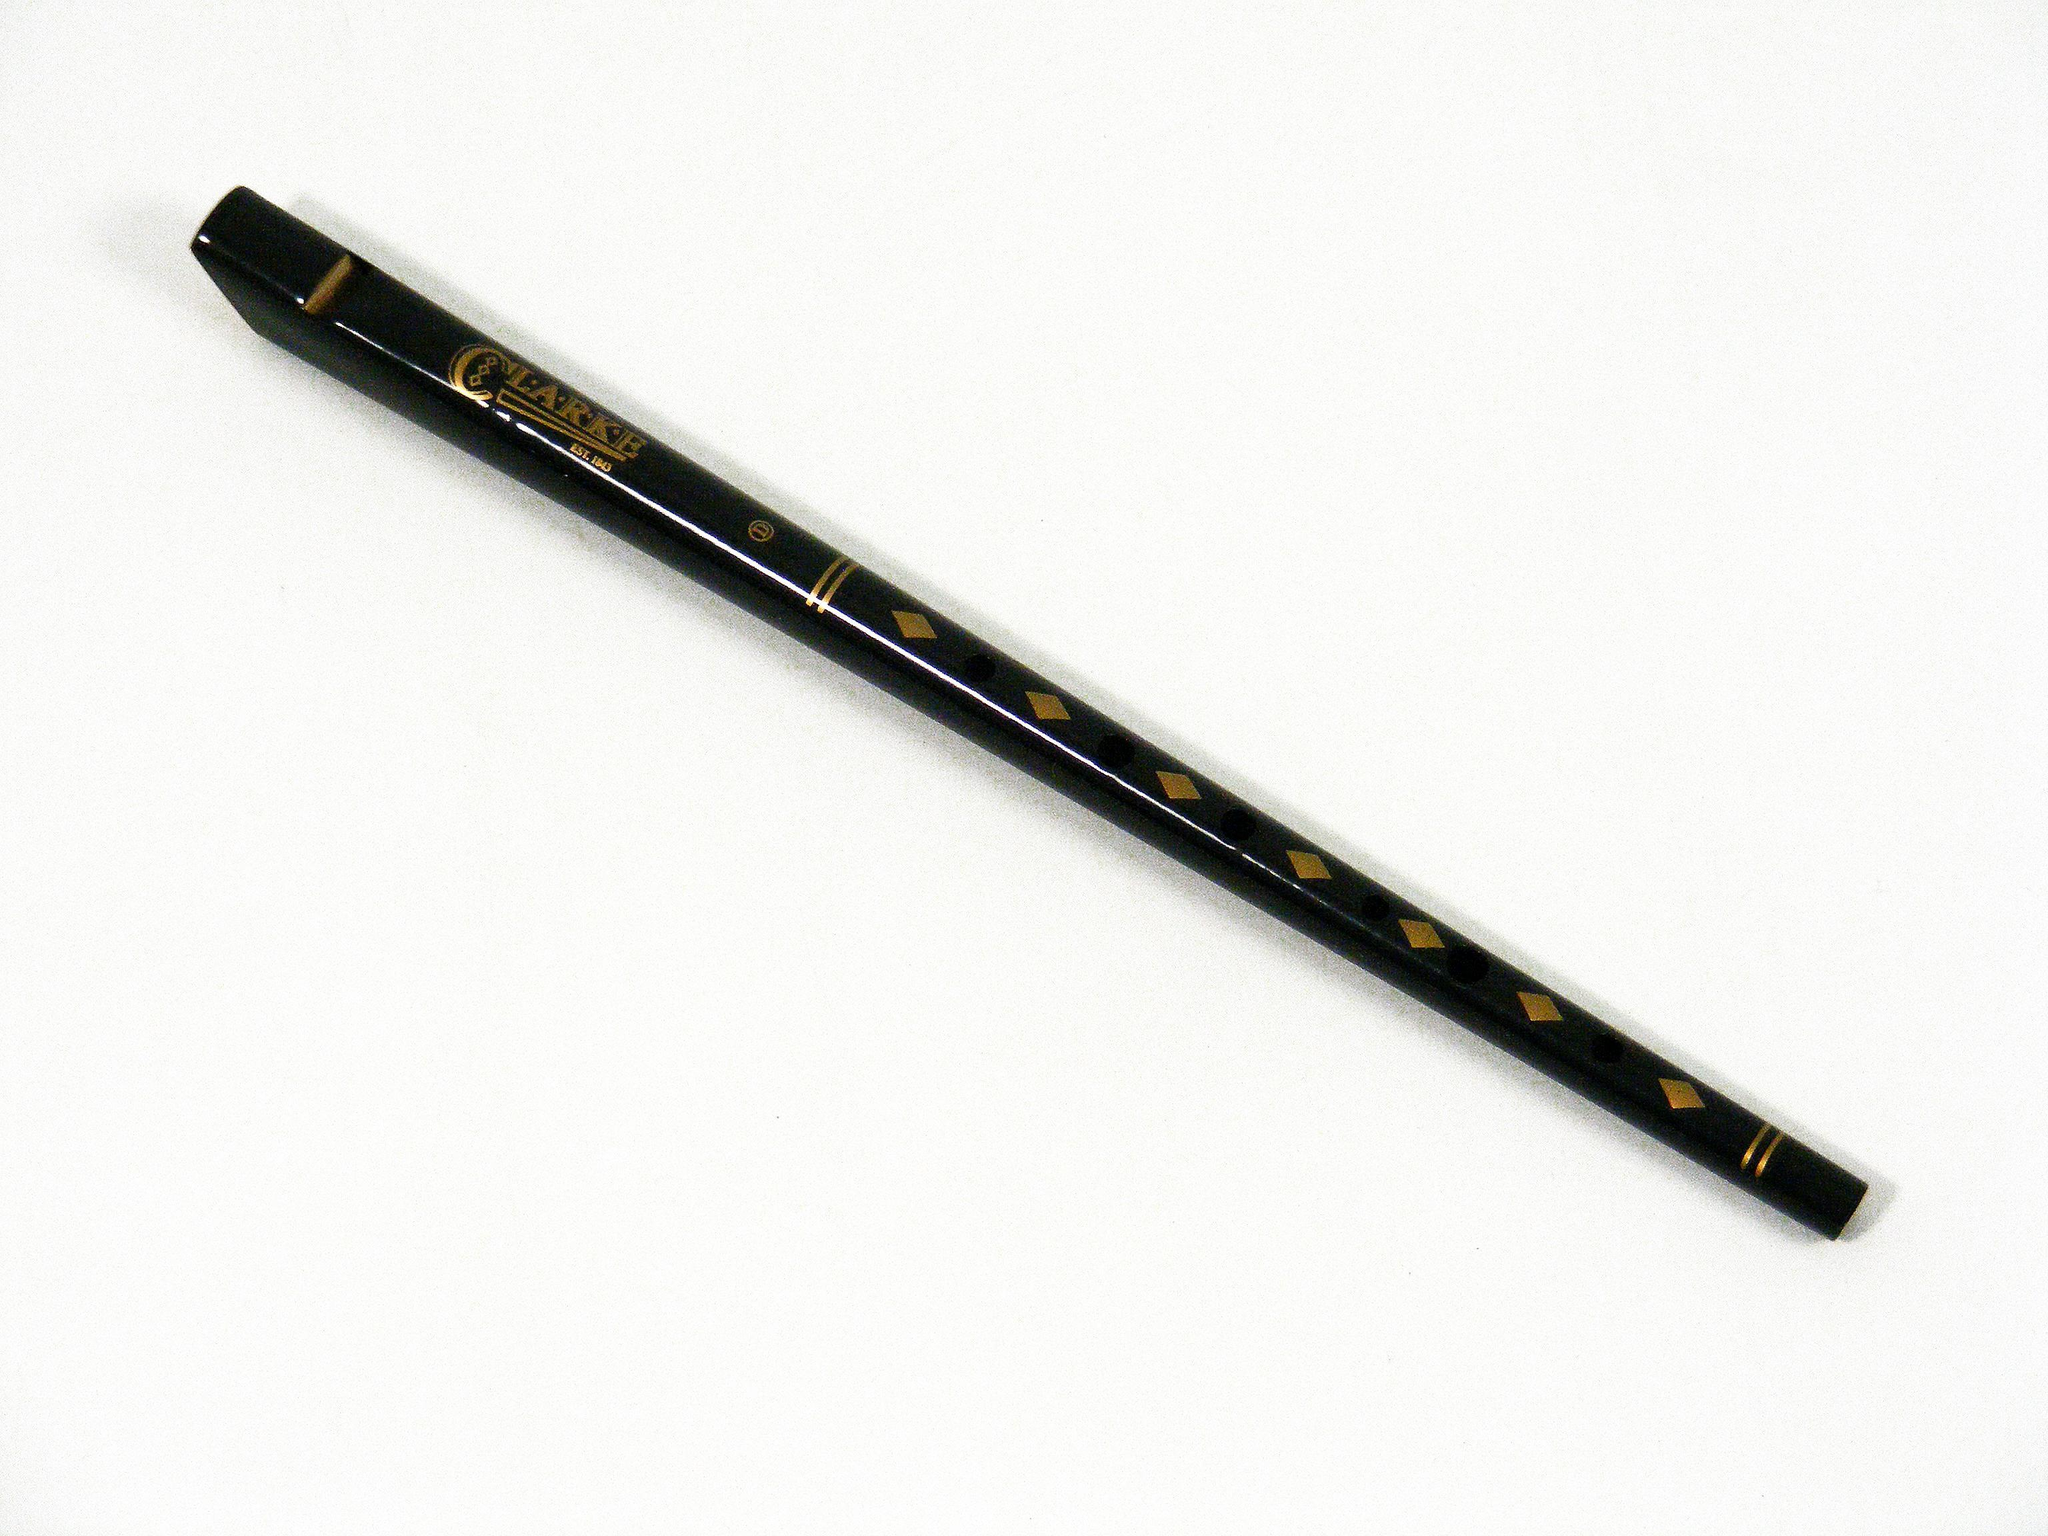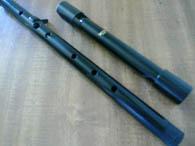The first image is the image on the left, the second image is the image on the right. Analyze the images presented: Is the assertion "There is a single flute in the left image." valid? Answer yes or no. Yes. The first image is the image on the left, the second image is the image on the right. Evaluate the accuracy of this statement regarding the images: "One image contains a single flute, and the other image shows two silver metal ends that overlap.". Is it true? Answer yes or no. No. 